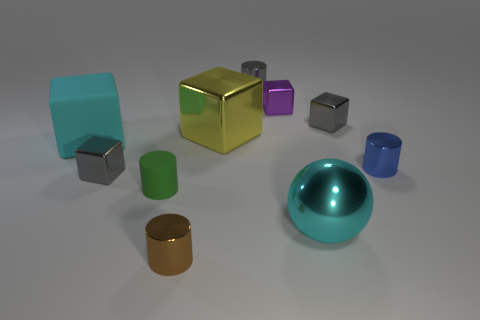Subtract all small metal blocks. How many blocks are left? 2 Subtract all green balls. How many gray blocks are left? 2 Subtract 1 cylinders. How many cylinders are left? 3 Subtract all green cylinders. How many cylinders are left? 3 Subtract all balls. How many objects are left? 9 Subtract all red metallic things. Subtract all cylinders. How many objects are left? 6 Add 8 small green rubber cylinders. How many small green rubber cylinders are left? 9 Add 8 large cyan metal balls. How many large cyan metal balls exist? 9 Subtract 1 gray cylinders. How many objects are left? 9 Subtract all yellow spheres. Subtract all green cylinders. How many spheres are left? 1 